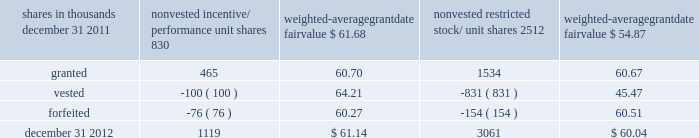To determine stock-based compensation expense , the grant- date fair value is applied to the options granted with a reduction for estimated forfeitures .
We recognize compensation expense for stock options on a straight-line basis over the pro rata vesting period .
At december 31 , 2011 and 2010 , options for 12337000 and 13397000 shares of common stock were exercisable at a weighted-average price of $ 106.08 and $ 118.21 , respectively .
The total intrinsic value of options exercised during 2012 , 2011 and 2010 was $ 37 million , $ 4 million and $ 5 million .
Cash received from option exercises under all incentive plans for 2012 , 2011 and 2010 was approximately $ 118 million , $ 41 million and $ 15 million , respectively .
The actual tax benefit realized for tax deduction purposes from option exercises under all incentive plans for 2012 , 2011 and 2010 was approximately $ 41 million , $ 14 million and $ 5 million , respectively .
There were no options granted in excess of market value in 2012 , 2011 or 2010 .
Shares of common stock available during the next year for the granting of options and other awards under the incentive plans were 29192854 at december 31 , 2012 .
Total shares of pnc common stock authorized for future issuance under equity compensation plans totaled 30537674 shares at december 31 , 2012 , which includes shares available for issuance under the incentive plans and the employee stock purchase plan ( espp ) as described below .
During 2012 , we issued approximately 1.7 million shares from treasury stock in connection with stock option exercise activity .
As with past exercise activity , we currently intend to utilize primarily treasury stock for any future stock option exercises .
Awards granted to non-employee directors in 2012 , 2011 and 2010 include 25620 , 27090 and 29040 deferred stock units , respectively , awarded under the outside directors deferred stock unit plan .
A deferred stock unit is a phantom share of our common stock , which requires liability accounting treatment until such awards are paid to the participants as cash .
As there are no vesting or service requirements on these awards , total compensation expense is recognized in full on awarded deferred stock units on the date of grant .
Incentive/performance unit share awards and restricted stock/unit awards the fair value of nonvested incentive/performance unit share awards and restricted stock/unit awards is initially determined based on prices not less than the market value of our common stock price on the date of grant .
The value of certain incentive/ performance unit share awards is subsequently remeasured based on the achievement of one or more financial and other performance goals generally over a three-year period .
The personnel and compensation committee of the board of directors approves the final award payout with respect to incentive/performance unit share awards .
Restricted stock/unit awards have various vesting periods generally ranging from 36 months to 60 months .
Beginning in 2012 , we incorporated several risk-related performance changes to certain incentive compensation programs .
In addition to achieving certain financial performance metrics relative to our peers , the final payout amount will be subject to a negative adjustment if pnc fails to meet certain risk-related performance metrics as specified in the award agreement .
However , the p&cc has the discretion to reduce any or all of this negative adjustment under certain circumstances .
These awards have a three-year performance period and are payable in either stock or a combination of stock and cash .
Additionally , performance-based restricted share units were granted in 2012 to certain of our executives in lieu of stock options , with generally the same terms and conditions as the 2011 awards of the same .
The weighted-average grant-date fair value of incentive/ performance unit share awards and restricted stock/unit awards granted in 2012 , 2011 and 2010 was $ 60.68 , $ 63.25 and $ 54.59 per share , respectively .
We recognize compensation expense for such awards ratably over the corresponding vesting and/or performance periods for each type of program .
Table 130 : nonvested incentive/performance unit share awards and restricted stock/unit awards 2013 rollforward shares in thousands nonvested incentive/ performance unit shares weighted- average date fair nonvested restricted stock/ shares weighted- average date fair .
In the chart above , the unit shares and related weighted- average grant-date fair value of the incentive/performance awards exclude the effect of dividends on the underlying shares , as those dividends will be paid in cash .
At december 31 , 2012 , there was $ 86 million of unrecognized deferred compensation expense related to nonvested share- based compensation arrangements granted under the incentive plans .
This cost is expected to be recognized as expense over a period of no longer than five years .
The total fair value of incentive/performance unit share and restricted stock/unit awards vested during 2012 , 2011 and 2010 was approximately $ 55 million , $ 52 million and $ 39 million , respectively .
The pnc financial services group , inc .
2013 form 10-k 203 .
How many shares were exercisable from dec 2010-dec 2011? 
Computations: (12337000 + 13397000)
Answer: 25734000.0. To determine stock-based compensation expense , the grant- date fair value is applied to the options granted with a reduction for estimated forfeitures .
We recognize compensation expense for stock options on a straight-line basis over the pro rata vesting period .
At december 31 , 2011 and 2010 , options for 12337000 and 13397000 shares of common stock were exercisable at a weighted-average price of $ 106.08 and $ 118.21 , respectively .
The total intrinsic value of options exercised during 2012 , 2011 and 2010 was $ 37 million , $ 4 million and $ 5 million .
Cash received from option exercises under all incentive plans for 2012 , 2011 and 2010 was approximately $ 118 million , $ 41 million and $ 15 million , respectively .
The actual tax benefit realized for tax deduction purposes from option exercises under all incentive plans for 2012 , 2011 and 2010 was approximately $ 41 million , $ 14 million and $ 5 million , respectively .
There were no options granted in excess of market value in 2012 , 2011 or 2010 .
Shares of common stock available during the next year for the granting of options and other awards under the incentive plans were 29192854 at december 31 , 2012 .
Total shares of pnc common stock authorized for future issuance under equity compensation plans totaled 30537674 shares at december 31 , 2012 , which includes shares available for issuance under the incentive plans and the employee stock purchase plan ( espp ) as described below .
During 2012 , we issued approximately 1.7 million shares from treasury stock in connection with stock option exercise activity .
As with past exercise activity , we currently intend to utilize primarily treasury stock for any future stock option exercises .
Awards granted to non-employee directors in 2012 , 2011 and 2010 include 25620 , 27090 and 29040 deferred stock units , respectively , awarded under the outside directors deferred stock unit plan .
A deferred stock unit is a phantom share of our common stock , which requires liability accounting treatment until such awards are paid to the participants as cash .
As there are no vesting or service requirements on these awards , total compensation expense is recognized in full on awarded deferred stock units on the date of grant .
Incentive/performance unit share awards and restricted stock/unit awards the fair value of nonvested incentive/performance unit share awards and restricted stock/unit awards is initially determined based on prices not less than the market value of our common stock price on the date of grant .
The value of certain incentive/ performance unit share awards is subsequently remeasured based on the achievement of one or more financial and other performance goals generally over a three-year period .
The personnel and compensation committee of the board of directors approves the final award payout with respect to incentive/performance unit share awards .
Restricted stock/unit awards have various vesting periods generally ranging from 36 months to 60 months .
Beginning in 2012 , we incorporated several risk-related performance changes to certain incentive compensation programs .
In addition to achieving certain financial performance metrics relative to our peers , the final payout amount will be subject to a negative adjustment if pnc fails to meet certain risk-related performance metrics as specified in the award agreement .
However , the p&cc has the discretion to reduce any or all of this negative adjustment under certain circumstances .
These awards have a three-year performance period and are payable in either stock or a combination of stock and cash .
Additionally , performance-based restricted share units were granted in 2012 to certain of our executives in lieu of stock options , with generally the same terms and conditions as the 2011 awards of the same .
The weighted-average grant-date fair value of incentive/ performance unit share awards and restricted stock/unit awards granted in 2012 , 2011 and 2010 was $ 60.68 , $ 63.25 and $ 54.59 per share , respectively .
We recognize compensation expense for such awards ratably over the corresponding vesting and/or performance periods for each type of program .
Table 130 : nonvested incentive/performance unit share awards and restricted stock/unit awards 2013 rollforward shares in thousands nonvested incentive/ performance unit shares weighted- average date fair nonvested restricted stock/ shares weighted- average date fair .
In the chart above , the unit shares and related weighted- average grant-date fair value of the incentive/performance awards exclude the effect of dividends on the underlying shares , as those dividends will be paid in cash .
At december 31 , 2012 , there was $ 86 million of unrecognized deferred compensation expense related to nonvested share- based compensation arrangements granted under the incentive plans .
This cost is expected to be recognized as expense over a period of no longer than five years .
The total fair value of incentive/performance unit share and restricted stock/unit awards vested during 2012 , 2011 and 2010 was approximately $ 55 million , $ 52 million and $ 39 million , respectively .
The pnc financial services group , inc .
2013 form 10-k 203 .
What was the total weighted-average grant-date fair value of incentive/ performance unit share awards and restricted stock/unit awards granted in 2011 and 2010? 
Computations: (63.25 + 54.59)
Answer: 117.84. 